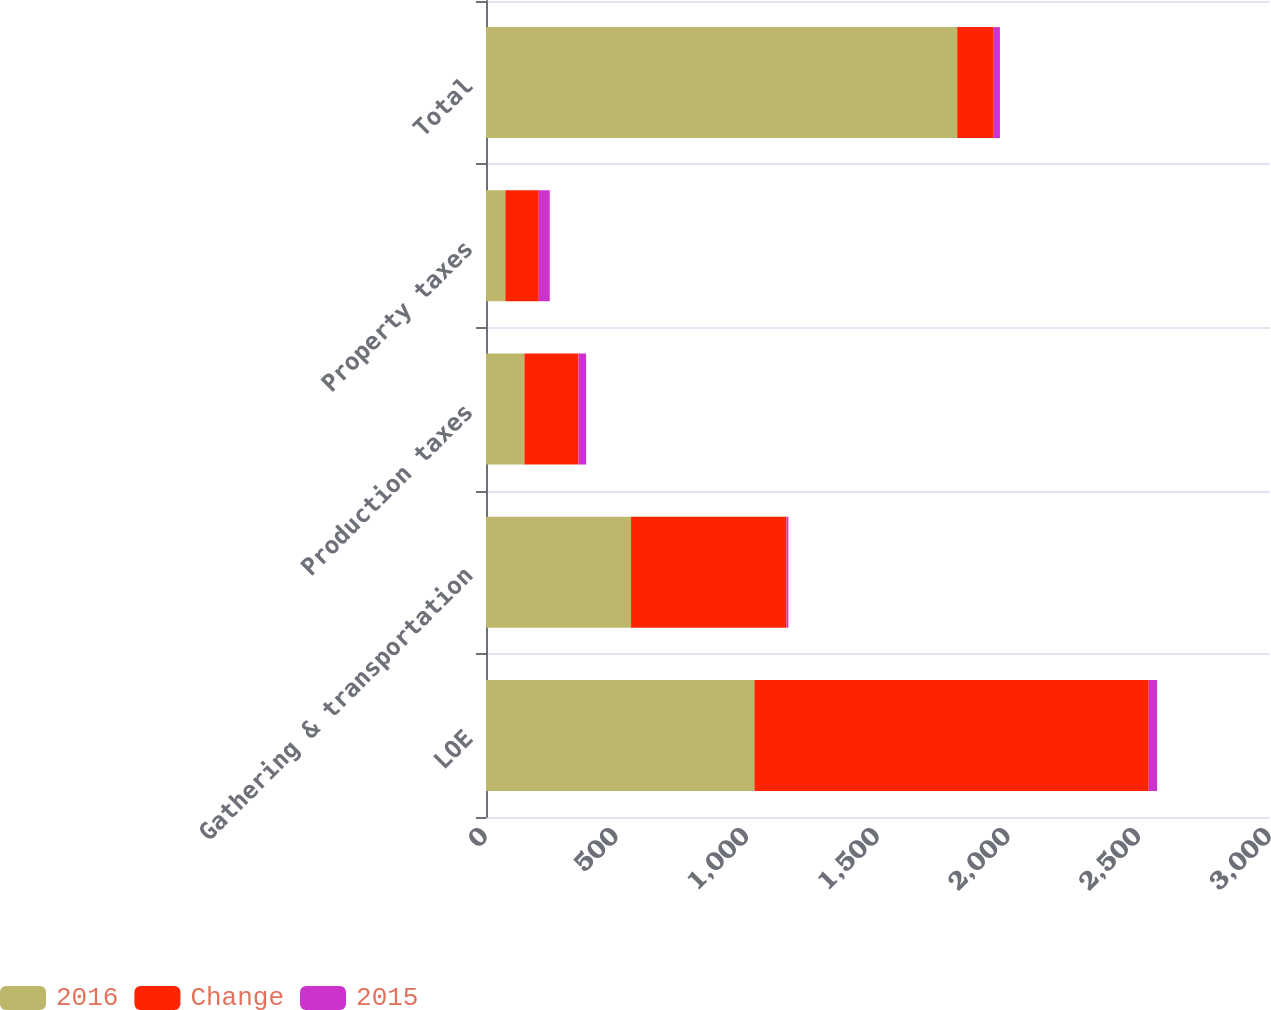<chart> <loc_0><loc_0><loc_500><loc_500><stacked_bar_chart><ecel><fcel>LOE<fcel>Gathering & transportation<fcel>Production taxes<fcel>Property taxes<fcel>Total<nl><fcel>2016<fcel>1027<fcel>555<fcel>147<fcel>74<fcel>1803<nl><fcel>Change<fcel>1509<fcel>595<fcel>207<fcel>128<fcel>137.5<nl><fcel>2015<fcel>32<fcel>7<fcel>29<fcel>42<fcel>26<nl></chart> 